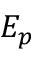Convert formula to latex. <formula><loc_0><loc_0><loc_500><loc_500>E _ { p }</formula> 